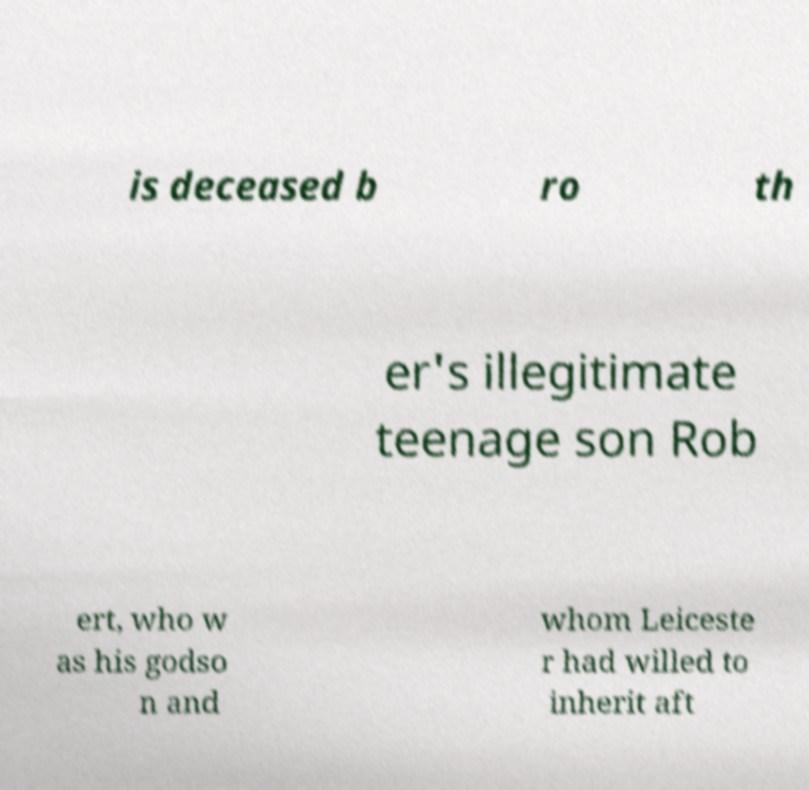There's text embedded in this image that I need extracted. Can you transcribe it verbatim? is deceased b ro th er's illegitimate teenage son Rob ert, who w as his godso n and whom Leiceste r had willed to inherit aft 